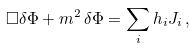<formula> <loc_0><loc_0><loc_500><loc_500>\Box \delta \Phi + m ^ { 2 } \, \delta \Phi = \sum _ { i } h _ { i } J _ { i } \, ,</formula> 